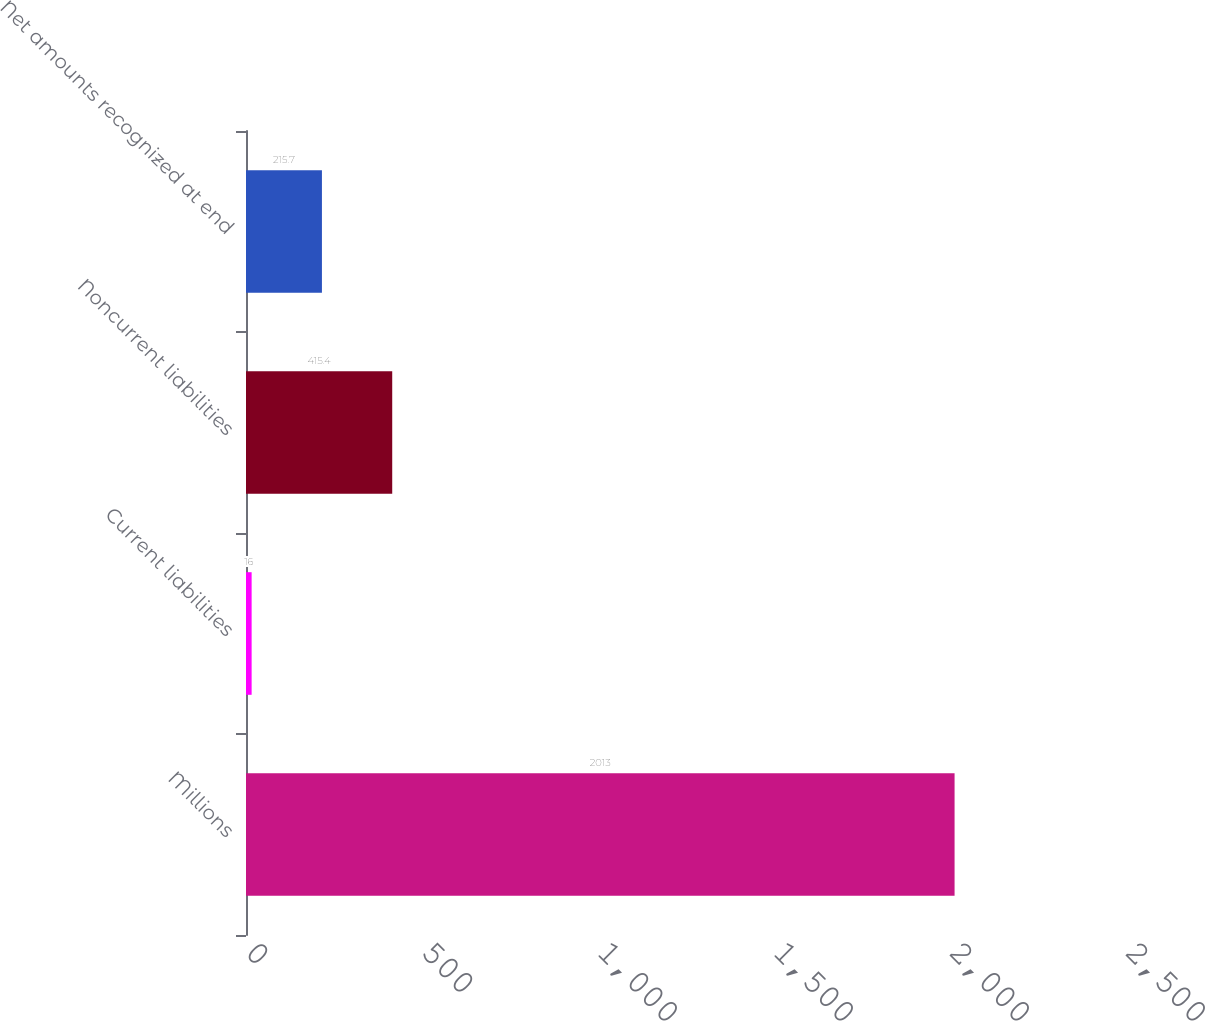<chart> <loc_0><loc_0><loc_500><loc_500><bar_chart><fcel>Millions<fcel>Current liabilities<fcel>Noncurrent liabilities<fcel>Net amounts recognized at end<nl><fcel>2013<fcel>16<fcel>415.4<fcel>215.7<nl></chart> 